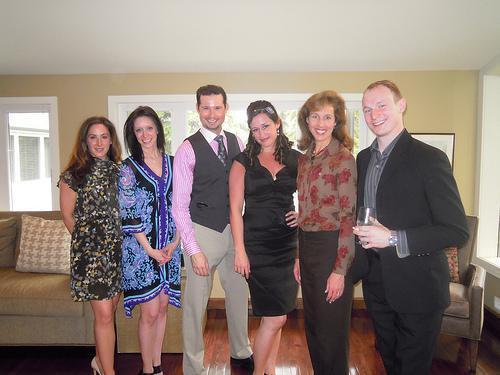How many people are there?
Give a very brief answer. 6. How many people are women?
Give a very brief answer. 4. How many people are men?
Give a very brief answer. 2. 